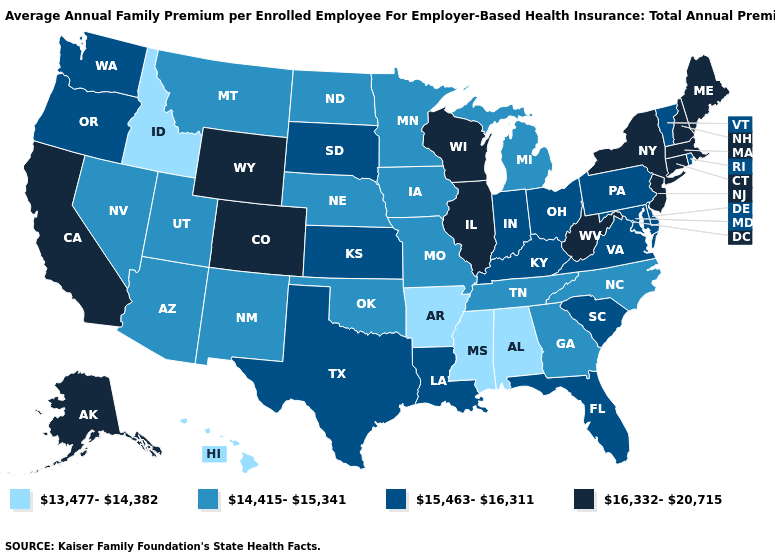Does Hawaii have the lowest value in the USA?
Keep it brief. Yes. Name the states that have a value in the range 14,415-15,341?
Quick response, please. Arizona, Georgia, Iowa, Michigan, Minnesota, Missouri, Montana, Nebraska, Nevada, New Mexico, North Carolina, North Dakota, Oklahoma, Tennessee, Utah. Does Hawaii have the lowest value in the West?
Give a very brief answer. Yes. What is the value of Washington?
Keep it brief. 15,463-16,311. Does Alaska have the highest value in the USA?
Be succinct. Yes. Is the legend a continuous bar?
Short answer required. No. What is the value of Florida?
Quick response, please. 15,463-16,311. What is the highest value in the USA?
Quick response, please. 16,332-20,715. Does Arkansas have the lowest value in the USA?
Give a very brief answer. Yes. Does Connecticut have the same value as Nevada?
Short answer required. No. Does Montana have the highest value in the West?
Write a very short answer. No. Does the first symbol in the legend represent the smallest category?
Answer briefly. Yes. What is the value of Wisconsin?
Write a very short answer. 16,332-20,715. What is the value of Indiana?
Quick response, please. 15,463-16,311. What is the highest value in the USA?
Quick response, please. 16,332-20,715. 